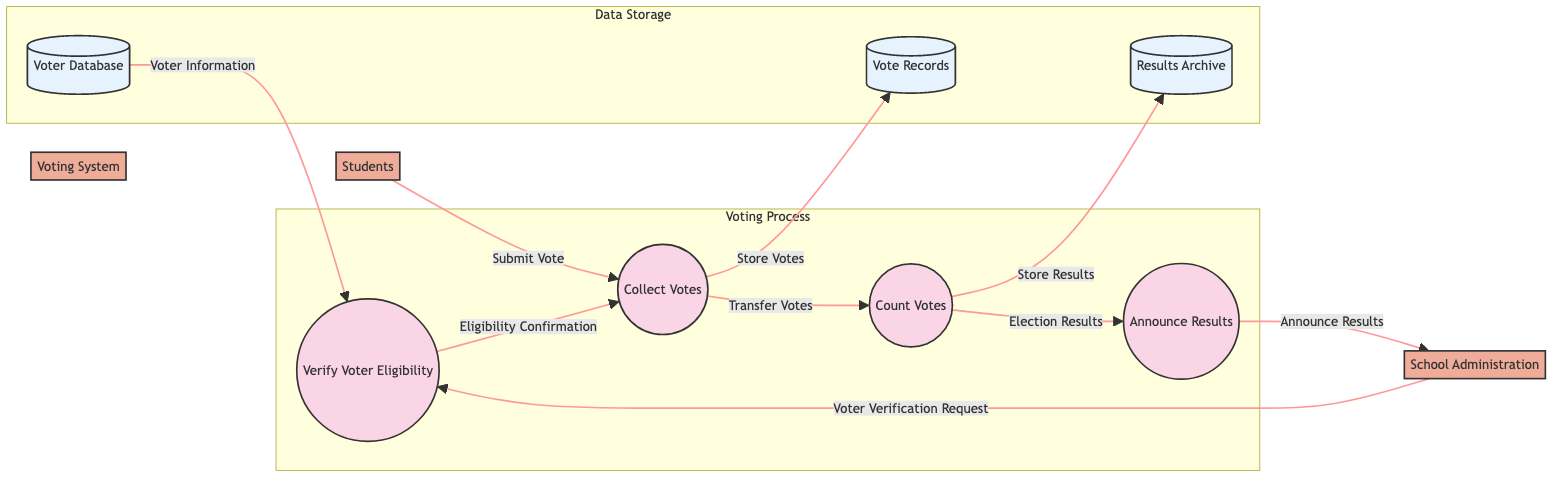What process collects votes from students? The diagram shows that the process responsible for collecting votes from students is labeled as “Collect Votes” (P1). This is linked directly to the students (E1) who submit their votes.
Answer: Collect Votes How many processes are in the voting system? The diagram displays four processes: Collect Votes (P1), Verify Voter Eligibility (P2), Count Votes (P3), and Announce Results (P4). Thus, the total number of processes is four.
Answer: 4 What data store holds the recorded votes? In the diagram, the data store labeled as “Vote Records” (D2) is designated for the secure storage of recorded votes.
Answer: Vote Records What is the relationship between the "Verify Voter Eligibility" process and the "Voter Database" data store? The diagram indicates that the “Verify Voter Eligibility” process (P2) receives “Voter Information” from the “Voter Database” (D1) to check for eligibility. The data flow shows this connection.
Answer: Provides necessary data for voter eligibility checks Which external entity oversees the integrity of the voting process? According to the diagram, the “School Administration” (E2) is identified as the external entity responsible for overseeing the integrity of the voting process.
Answer: School Administration What happens to votes after they are collected? The diagram indicates that after the votes are collected in the "Collect Votes" process (P1), they are transferred to the "Count Votes" process (P3) for tallying.
Answer: Transfer Votes Where are the final election results stored? Following the flow in the diagram, the final election results are securely stored in the “Results Archive” (D3) after counting the votes in the "Count Votes" process (P3).
Answer: Results Archive What confirms a voter's eligibility prior to vote recording? The diagram illustrates that the “Eligibility Confirmation” data flow sent from the “Verify Voter Eligibility” process (P2) confirms that voters are eligible before their votes are recorded in the “Collect Votes” process (P1).
Answer: Eligibility Confirmation What process communicates the election results to the school community? The diagram shows that the “Announce Results” process (P4) is responsible for communicating the election results to the school community, specifically to the school administration (E2).
Answer: Announce Results 